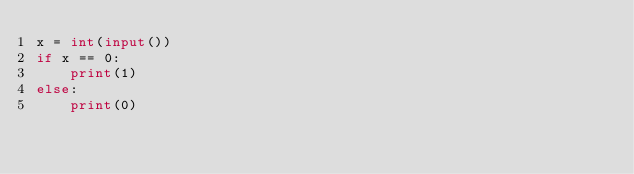Convert code to text. <code><loc_0><loc_0><loc_500><loc_500><_Python_>x = int(input())
if x == 0:
    print(1)
else:
    print(0)</code> 